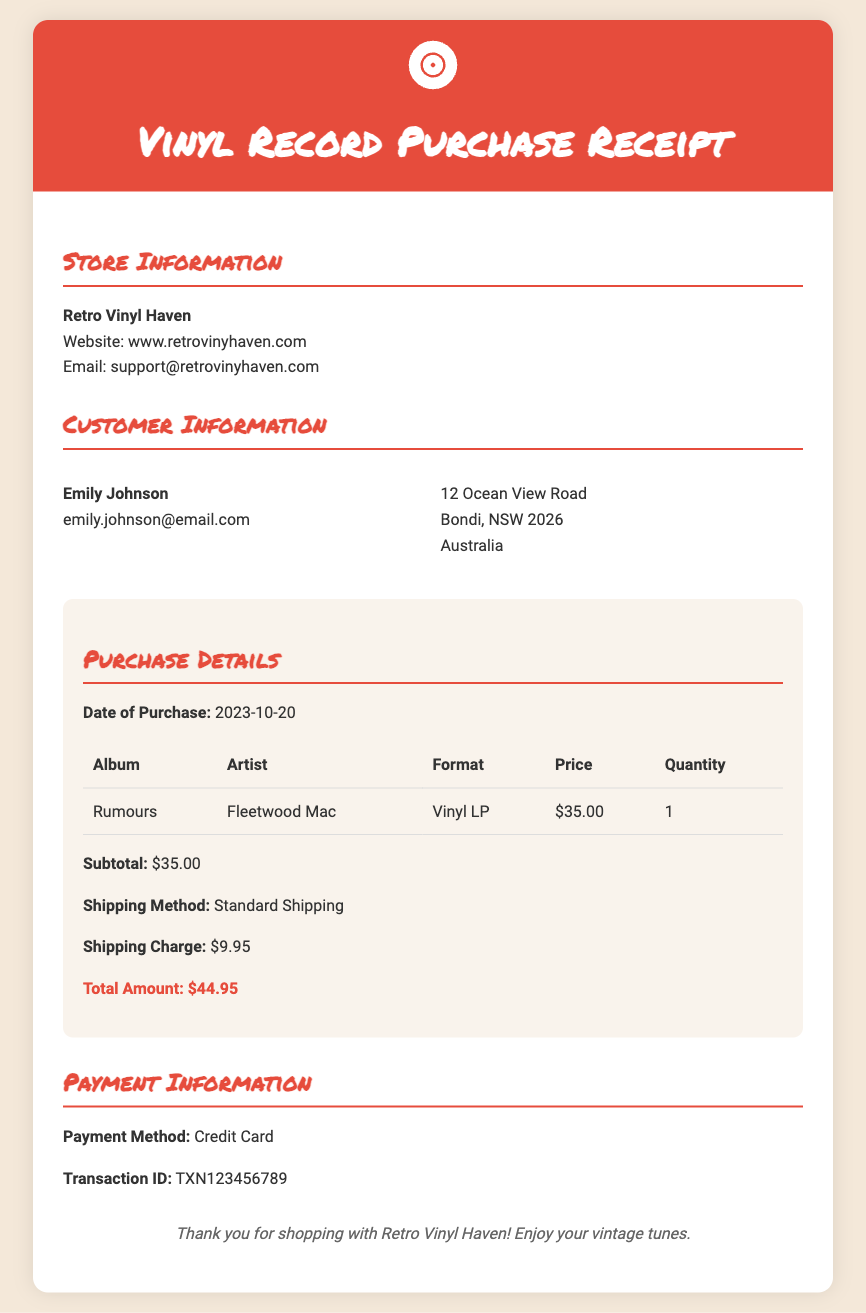What is the album name? The album name is specified in the Purchase Details section of the document.
Answer: Rumours Who is the artist? The artist is listed alongside the album name in the Purchase Details section.
Answer: Fleetwood Mac What is the date of purchase? The date of purchase is provided in the Purchase Details section of the document.
Answer: 2023-10-20 What is the shipping charge? The shipping charge is outlined in the Purchase Details section, specifically under Shipping Charge.
Answer: $9.95 What is the total amount? The total amount is the final figure calculated from the subtotal and shipping charges in the document.
Answer: $44.95 What payment method was used? The payment method is specified in the Payment Information section at the end of the document.
Answer: Credit Card How many vinyl records were purchased? The quantity purchased is shown in the Purchase Details section of the table.
Answer: 1 What is the name of the store? The name of the store is listed in the Store Information section at the top of the document.
Answer: Retro Vinyl Haven What is the email for customer support? The email address for customer support is provided in the Store Information section.
Answer: support@retrovinyhaven.com 